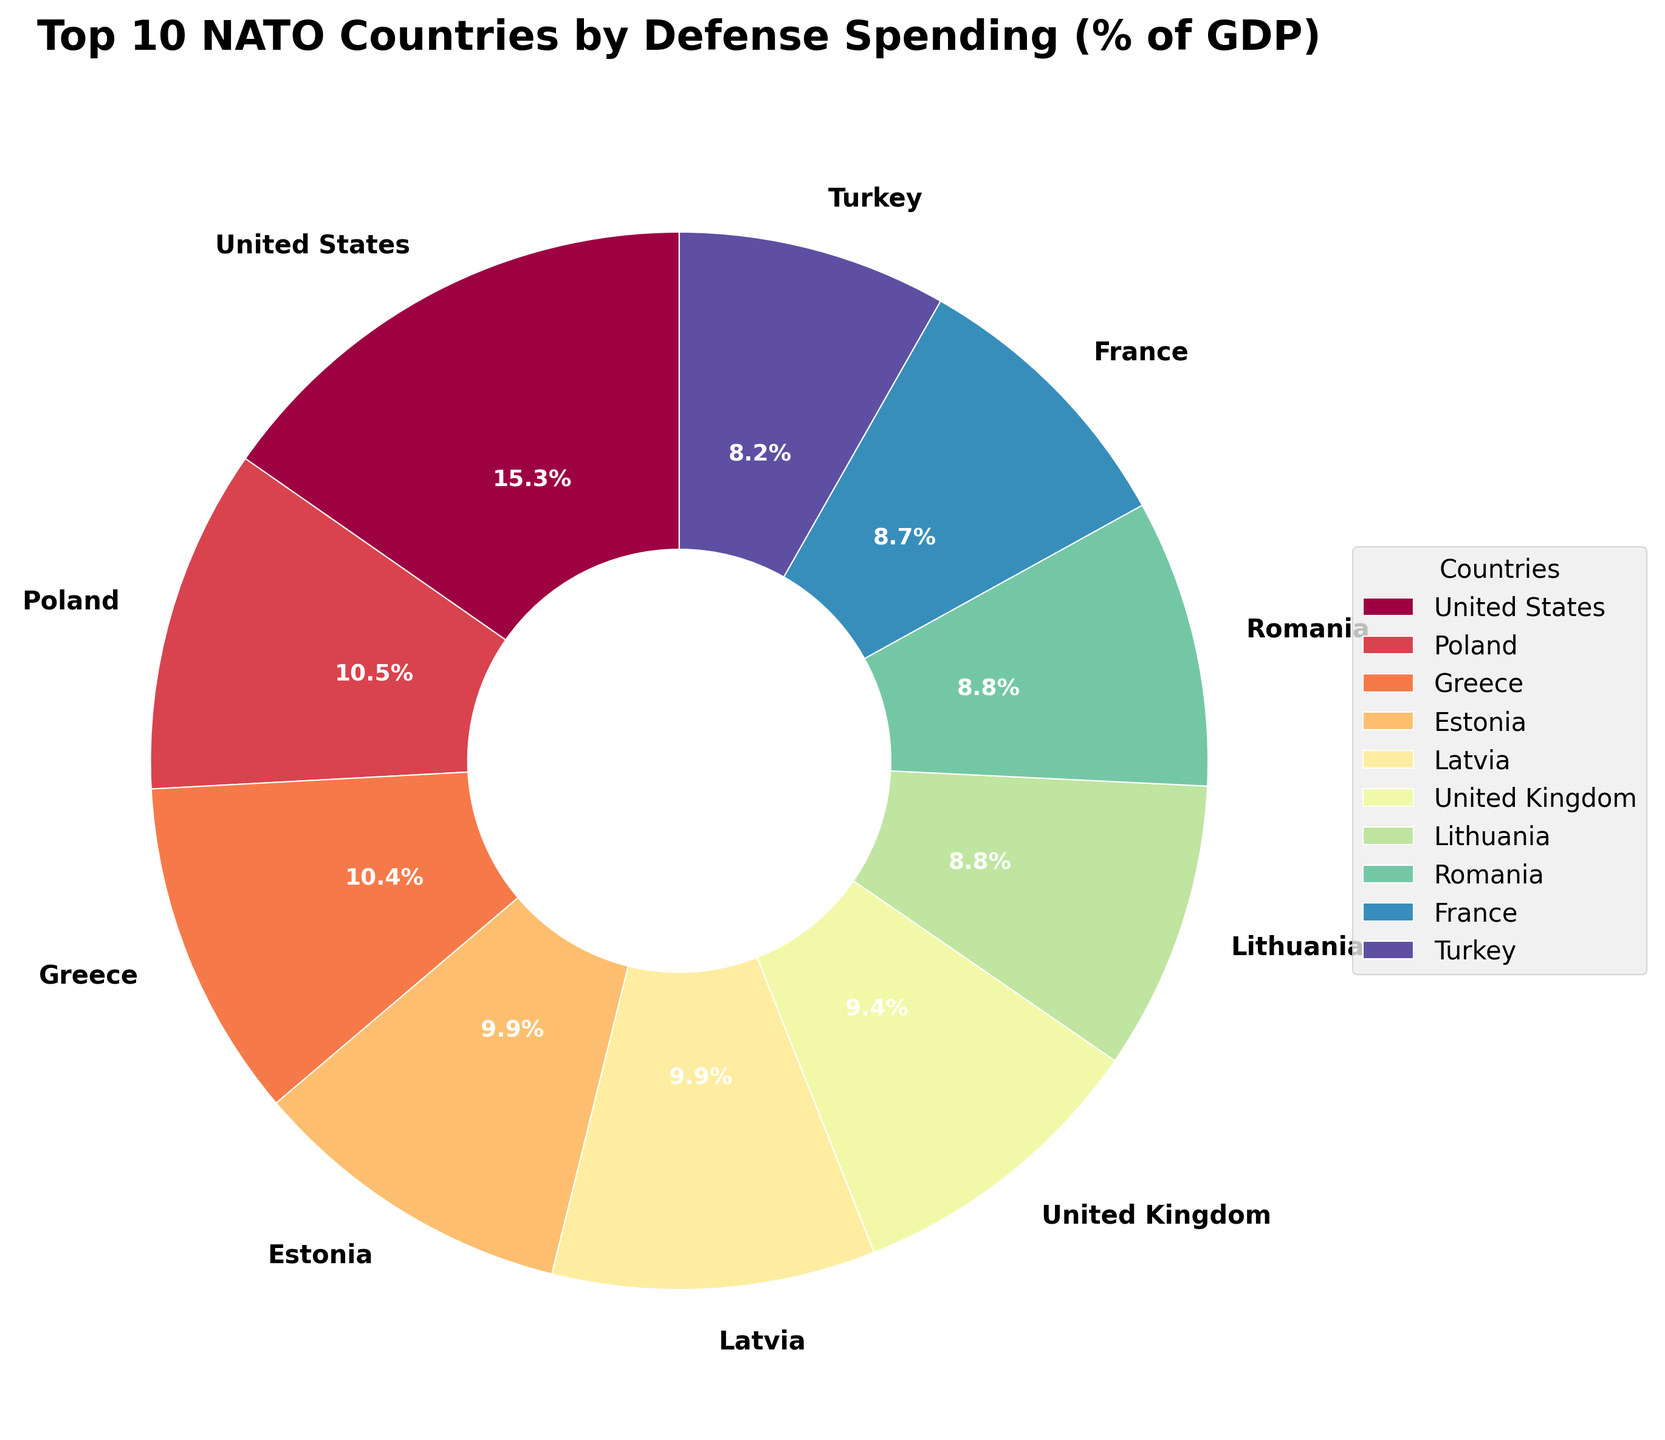Which NATO country has the highest defense spending as a percentage of GDP? The largest slice of the pie chart represents the country with the highest defense spending as a percentage of GDP. From the figure, the United States has the largest slice.
Answer: United States Which two countries have the closest defense spending percentages among the top 10? By examining the sizes of the pie slices, Estonia and Latvia have almost identical-sized slices, indicating their defense spending percentages are very close.
Answer: Estonia and Latvia What is the sum of defense spending percentages for the top 3 countries? The top 3 countries are the United States (3.52%), Poland (2.42%), and Greece (2.38%). Summing these values: 3.52 + 2.42 + 2.38 = 8.32
Answer: 8.32% Which country in the top 10 spends the smallest percentage of its GDP on defense, and what is that percentage? The smallest slice among the top 10 countries belongs to France, which spends 2.01% of its GDP on defense.
Answer: France, 2.01% Which country has a higher defense spending percentage: Greece or Estonia? By comparing the sizes of the pie slices, it's evident that Greece (2.38%) has a higher defense spending percentage than Estonia (2.28%).
Answer: Greece How many countries have defense spending percentages between 2% and 2.4% (inclusive) in the top 10? From the pie chart, the following countries fall within this range: Greece (2.38%), Poland (2.42%), Estonia (2.28%), Latvia (2.27%), and Lithuania (2.03%). This totals to 5 countries.
Answer: 5 What is the average defense spending percentage of the bottom 5 countries within the top 10? The bottom 5 countries within the top 10 are Latvia (2.27%), Lithuania (2.03%), Romania (2.02%), France (2.01%), and Turkey (1.89%). Averaging these values: (2.27 + 2.03 + 2.02 + 2.01 + 1.89) / 5 = 2.044
Answer: 2.04% What is the difference in defense spending percentages between the country with the highest spending and the country with the lowest spending in the top 10? The highest defense spending percentage is by the United States (3.52%), and the lowest in the top 10 is by France (2.01%). The difference is: 3.52 - 2.01 = 1.51
Answer: 1.51% Which NATO country in the top 10 is represented by the slice with a green color? Each pie slice represents a different country, and the pie chart uses the Spectral color map. Without seeing the colors, the exact country may not be identifiable without visual inspection, typically this question would be answered by directly seeing the plot.
Answer: Depends on plot Is the defense spending percentage of Poland greater than that of Lithuania and Romania combined? Poland's defense spending percentage is 2.42%. Lithuania's is 2.03% and Romania's is 2.02%. Summing Lithuania and Romania: 2.03 + 2.02 = 4.05. So, 2.42 is less than 4.05.
Answer: No 